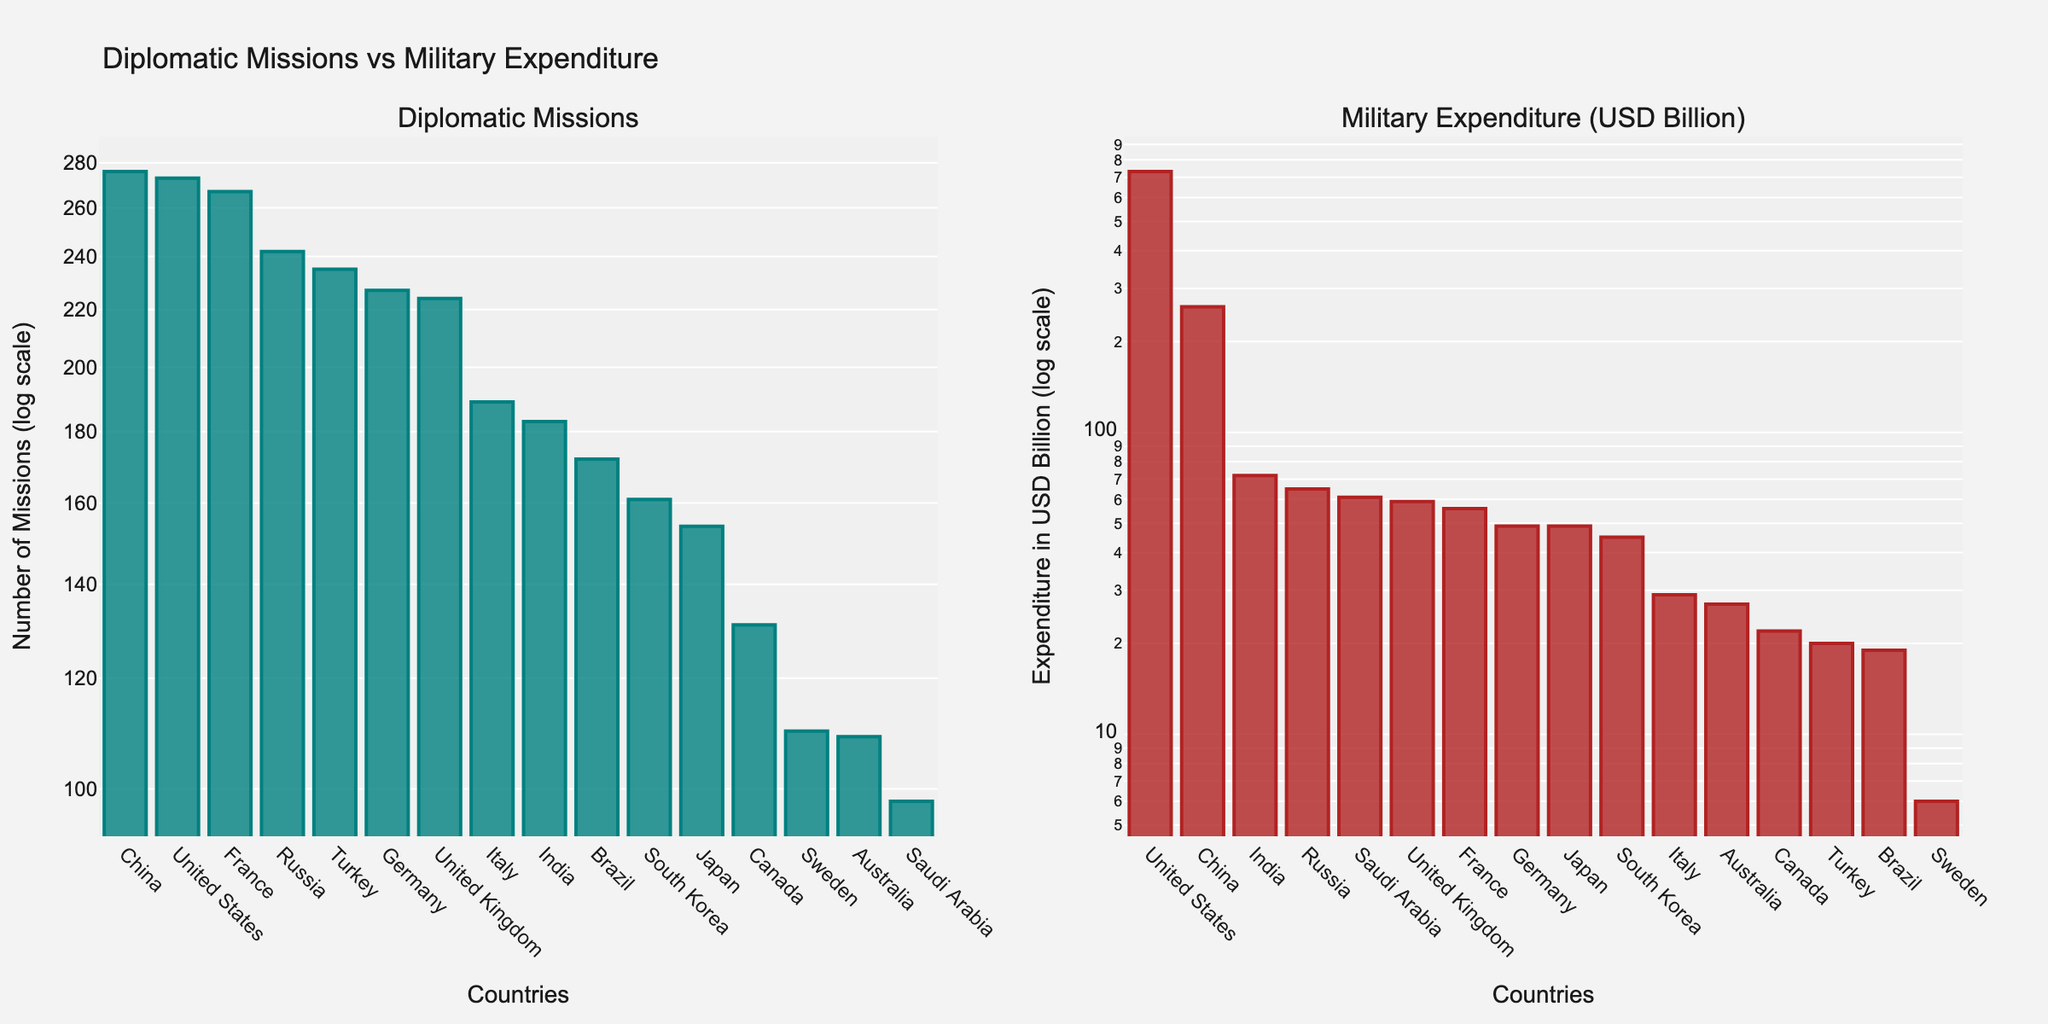what is the title of the figure? The title of the figure is located at the top of the plot and should be read directly from there.
Answer: Diplomatic Missions vs Military Expenditure How many countries have Diplomatic Missions numbers greater than 200? To answer this, you need to count the bars in the left subplot that have a height corresponding to more than 200 Diplomatic Missions.
Answer: 6 Which country has the highest number of Diplomatic Missions? To determine this, identify the tallest bar in the left subplot where Diplomatic Missions are plotted.
Answer: China Which country has the lowest Military Expenditure? To answer this, look for the shortest bar in the right subplot, where Military Expenditure in USD Billion is plotted.
Answer: Sweden Are there any countries with more Diplomatic Missions than Military Expenditure in USD Billion? Compare the heights of the bars for each country across the two subplots; specifically look for cases where the left bar (Diplomatic Missions) is taller than the right bar (Military Expenditure).
Answer: Yes How does Saudi Arabia's Military Expenditure compare to its Diplomatic Missions? Examine Saudi Arabia's bars in both subplots; the right subplot will show the Military Expenditure and the left subplot will show Diplomatic Missions. Compare their heights.
Answer: Higher Military Expenditure Which countries have both Diplomatic Missions and Military Expenditure less than 50? Identify the countries where both the left and right bars for that country fall below the value 50 on the respective y-axes.
Answer: Sweden What is the relationship between Diplomatic Missions and Military Expenditure for the United States? Compare the height of the bars corresponding to the United States in both subplots.
Answer: More Military Expenditure Which subplot shows a wider range of values on the y-axis? Look at both subplots and compare the range of values shown on the y-axes to identify which one spans a greater range.
Answer: Military Expenditure Does Russia have more Diplomatic Missions or higher Military Expenditure? Compare the heights of Russia's bars in both subplots to see which one is greater.
Answer: Diplomatic Missions 